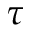Convert formula to latex. <formula><loc_0><loc_0><loc_500><loc_500>\tau</formula> 